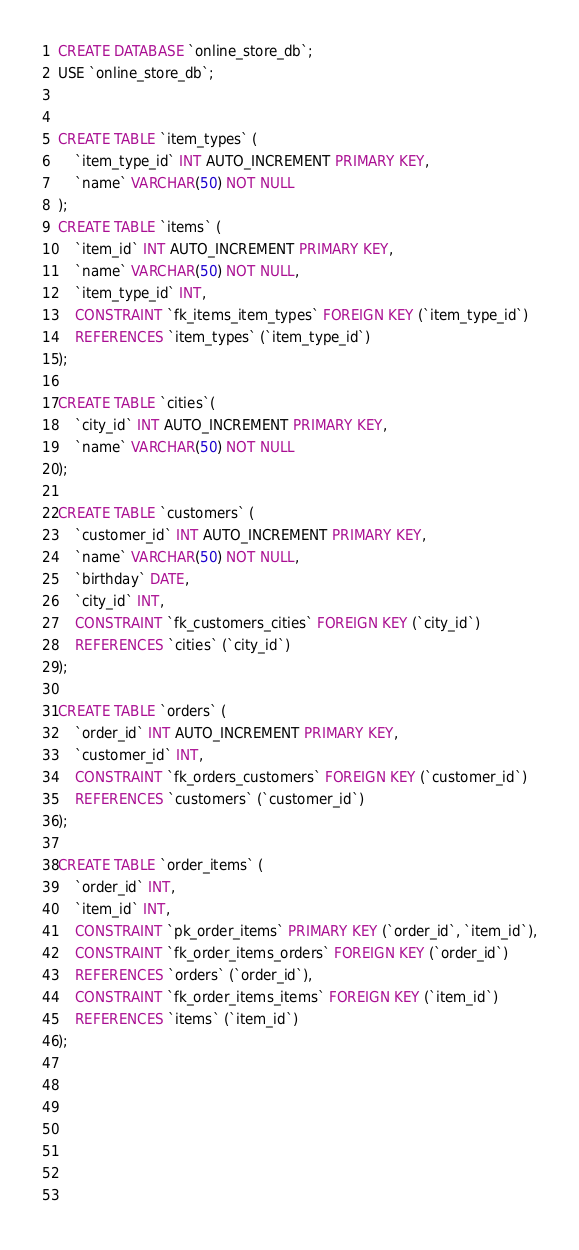<code> <loc_0><loc_0><loc_500><loc_500><_SQL_>CREATE DATABASE `online_store_db`;
USE `online_store_db`;


CREATE TABLE `item_types` (
	`item_type_id` INT AUTO_INCREMENT PRIMARY KEY,
	`name` VARCHAR(50) NOT NULL
);
CREATE TABLE `items` (
	`item_id` INT AUTO_INCREMENT PRIMARY KEY,
	`name` VARCHAR(50) NOT NULL,
	`item_type_id` INT,
	CONSTRAINT `fk_items_item_types` FOREIGN KEY (`item_type_id`)
	REFERENCES `item_types` (`item_type_id`)
);

CREATE TABLE `cities`(
	`city_id` INT AUTO_INCREMENT PRIMARY KEY,
	`name` VARCHAR(50) NOT NULL
);

CREATE TABLE `customers` (
	`customer_id` INT AUTO_INCREMENT PRIMARY KEY,
	`name` VARCHAR(50) NOT NULL,
	`birthday` DATE,
	`city_id` INT,
	CONSTRAINT `fk_customers_cities` FOREIGN KEY (`city_id`)
	REFERENCES `cities` (`city_id`)
);

CREATE TABLE `orders` (
	`order_id` INT AUTO_INCREMENT PRIMARY KEY,
	`customer_id` INT,
	CONSTRAINT `fk_orders_customers` FOREIGN KEY (`customer_id`)
	REFERENCES `customers` (`customer_id`)
);

CREATE TABLE `order_items` (
	`order_id` INT,
	`item_id` INT,
	CONSTRAINT `pk_order_items` PRIMARY KEY (`order_id`, `item_id`),
	CONSTRAINT `fk_order_items_orders` FOREIGN KEY (`order_id`)
	REFERENCES `orders` (`order_id`),
	CONSTRAINT `fk_order_items_items` FOREIGN KEY (`item_id`)
	REFERENCES `items` (`item_id`)
);


	
	
	

	</code> 